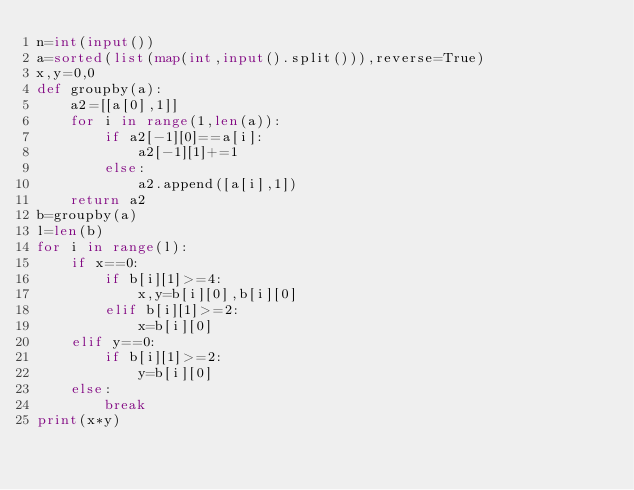<code> <loc_0><loc_0><loc_500><loc_500><_Python_>n=int(input())
a=sorted(list(map(int,input().split())),reverse=True)
x,y=0,0
def groupby(a):
    a2=[[a[0],1]]
    for i in range(1,len(a)):
        if a2[-1][0]==a[i]:
            a2[-1][1]+=1
        else:
            a2.append([a[i],1])
    return a2
b=groupby(a)
l=len(b)
for i in range(l):
    if x==0:
        if b[i][1]>=4:
            x,y=b[i][0],b[i][0]
        elif b[i][1]>=2:
            x=b[i][0]
    elif y==0:
        if b[i][1]>=2:
            y=b[i][0]
    else:
        break
print(x*y)</code> 